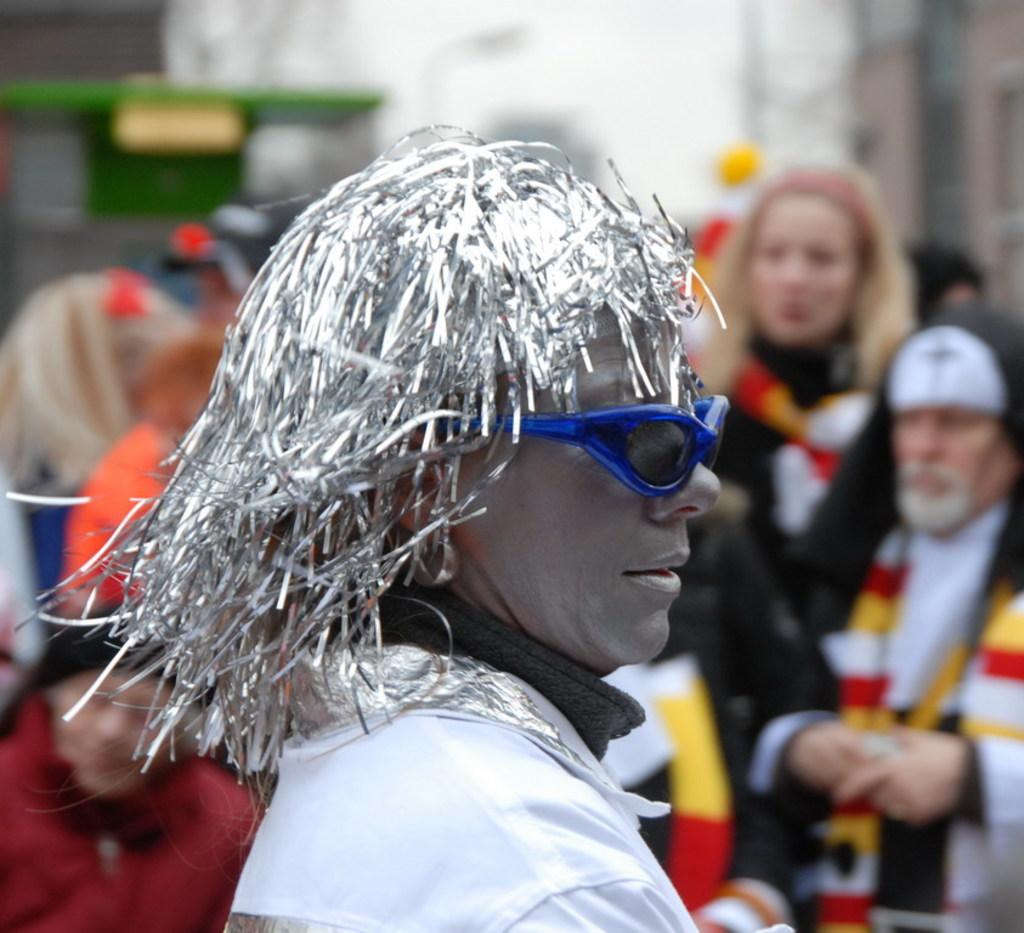Who is the main subject in the image? There is a person in the center of the image. What can be observed about the person's appearance? The person is wearing glasses and a costume. Can you describe the surrounding environment in the image? There are other people in the background of the image. What type of dog can be seen playing with a marble in the image? There is no dog or marble present in the image; it features a person wearing glasses and a costume, with other people in the background. 